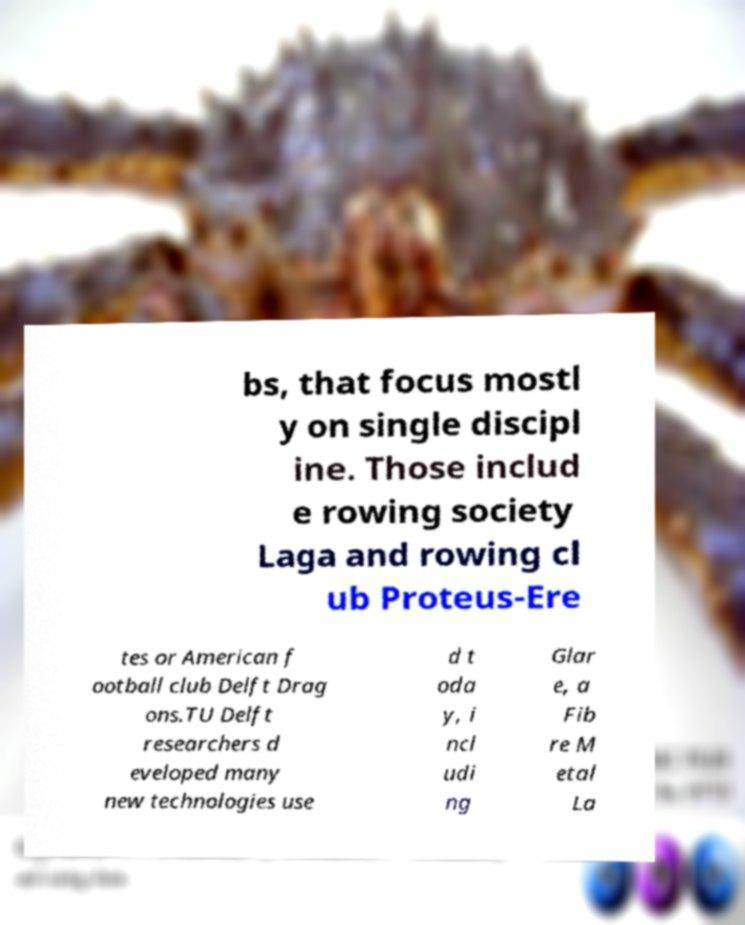For documentation purposes, I need the text within this image transcribed. Could you provide that? bs, that focus mostl y on single discipl ine. Those includ e rowing society Laga and rowing cl ub Proteus-Ere tes or American f ootball club Delft Drag ons.TU Delft researchers d eveloped many new technologies use d t oda y, i ncl udi ng Glar e, a Fib re M etal La 